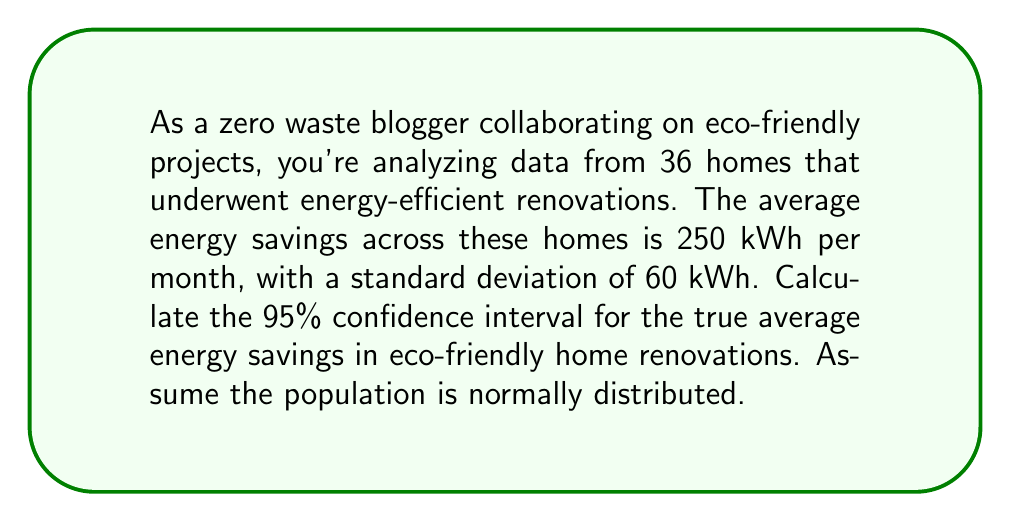Help me with this question. To calculate the 95% confidence interval, we'll follow these steps:

1. Identify the given information:
   - Sample size (n) = 36
   - Sample mean ($\bar{x}$) = 250 kWh
   - Sample standard deviation (s) = 60 kWh
   - Confidence level = 95%

2. Determine the critical value:
   For a 95% confidence level and n-1 = 35 degrees of freedom, the t-value is approximately 2.030 (from t-distribution table).

3. Calculate the standard error (SE) of the mean:
   $SE = \frac{s}{\sqrt{n}} = \frac{60}{\sqrt{36}} = \frac{60}{6} = 10$

4. Calculate the margin of error (ME):
   $ME = t \cdot SE = 2.030 \cdot 10 = 20.30$

5. Calculate the confidence interval:
   Lower bound: $\bar{x} - ME = 250 - 20.30 = 229.70$
   Upper bound: $\bar{x} + ME = 250 + 20.30 = 270.30$

Therefore, the 95% confidence interval is (229.70, 270.30) kWh.
Answer: (229.70, 270.30) kWh 